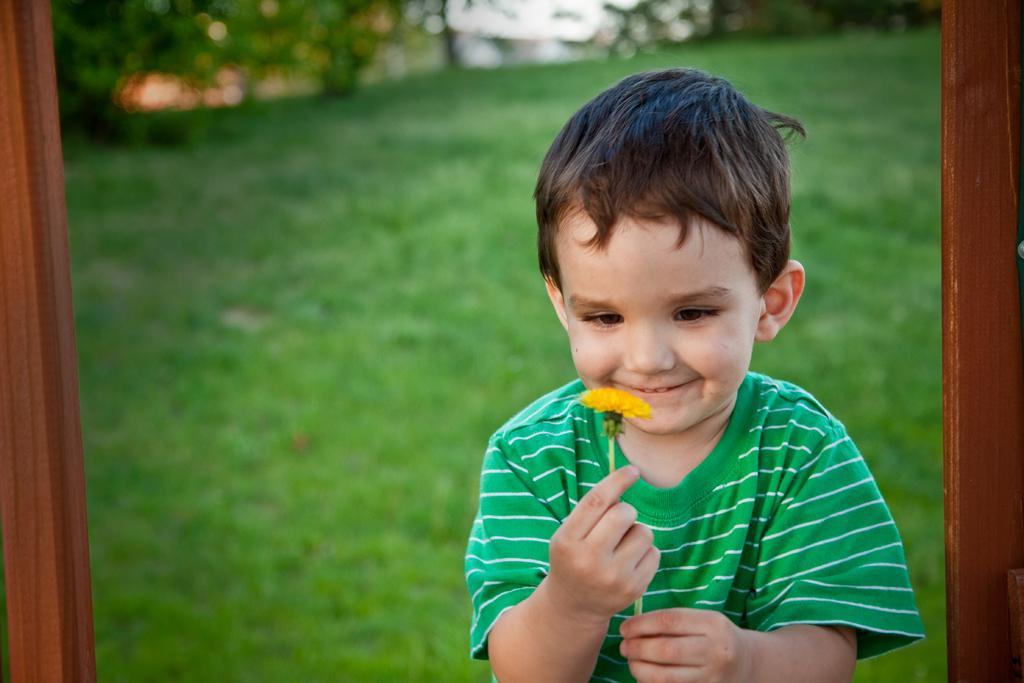Describe this image in one or two sentences. In front of the picture, we see a boy who is wearing a green T-shirt is standing and he is holding a yellow flower in his hands. He is smiling. At the bottom, we see the grass. On either side of the picture, we see the wooden poles in brown color. There are trees and buildings in the background. This picture is blurred in the background. 